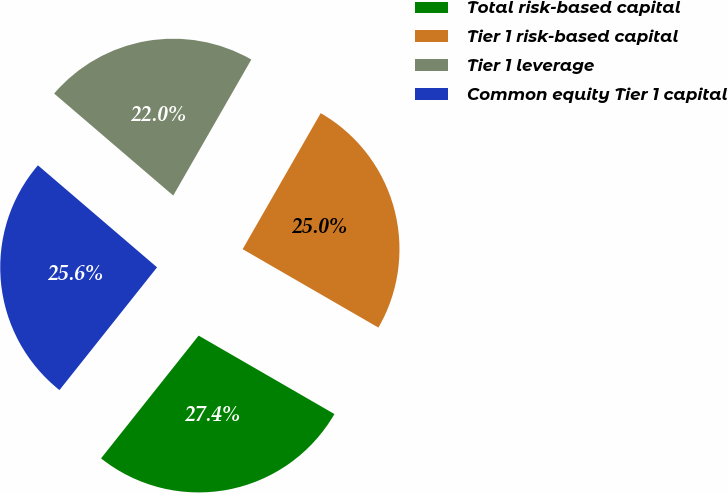Convert chart to OTSL. <chart><loc_0><loc_0><loc_500><loc_500><pie_chart><fcel>Total risk-based capital<fcel>Tier 1 risk-based capital<fcel>Tier 1 leverage<fcel>Common equity Tier 1 capital<nl><fcel>27.35%<fcel>25.04%<fcel>22.02%<fcel>25.58%<nl></chart> 